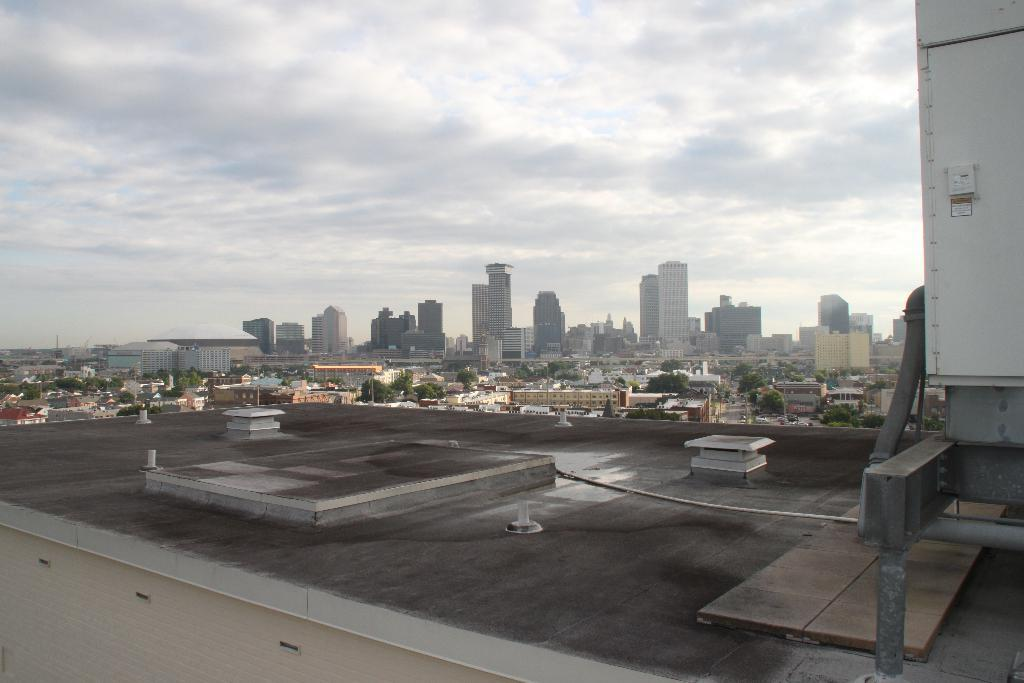What is the main subject of the image? The main subject of the image is the top of a building. What can be seen in the middle of the image? There are trees in the middle of the image. What else is visible in the image besides the building and trees? There are other buildings visible in the image. What is visible at the top of the image? The sky is visible at the top of the image. How far away is the transport system from the building in the image? There is no transport system visible in the image, so it is not possible to determine the distance. 